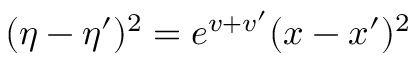<formula> <loc_0><loc_0><loc_500><loc_500>( \eta - \eta ^ { \prime } ) ^ { 2 } = e ^ { v + v ^ { \prime } } ( x - x ^ { \prime } ) ^ { 2 }</formula> 